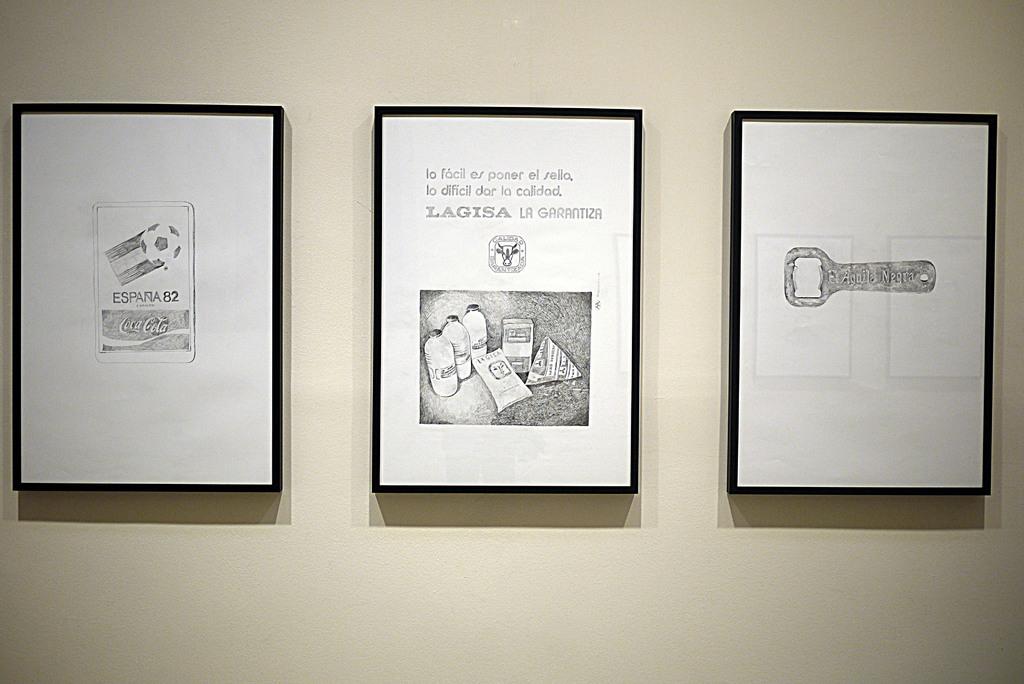What drink brand is feature on the left art?
Your answer should be compact. Coca cola. 